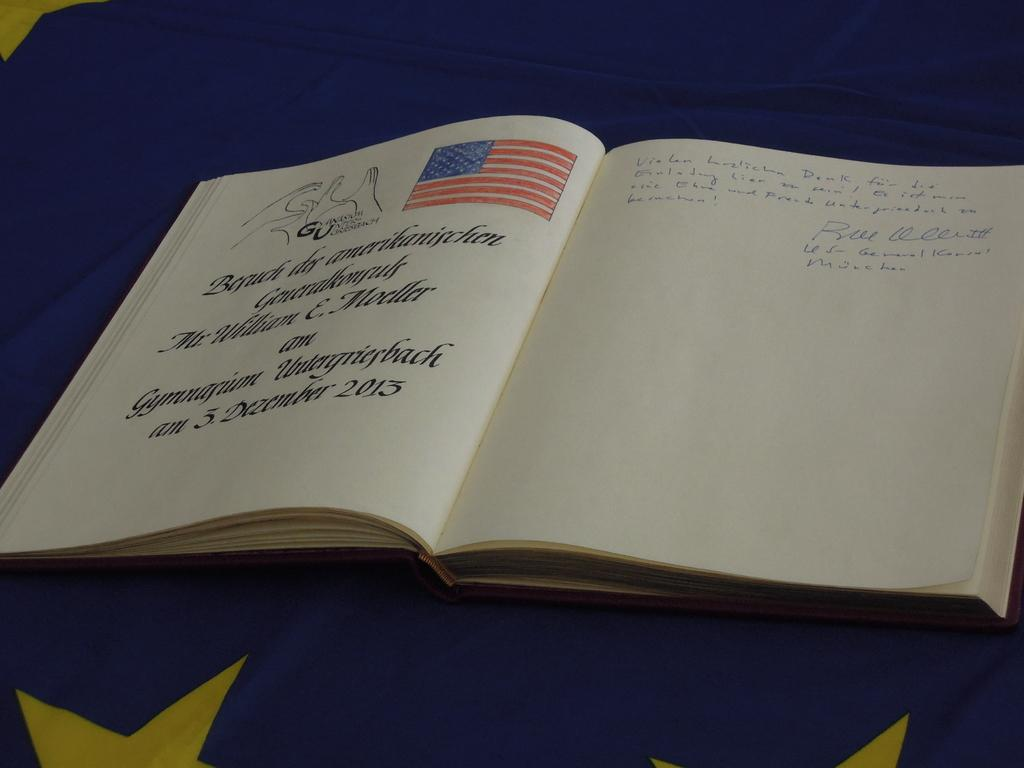<image>
Relay a brief, clear account of the picture shown. A page of this book written on the 3rd of December in 2015 features an American flag. 